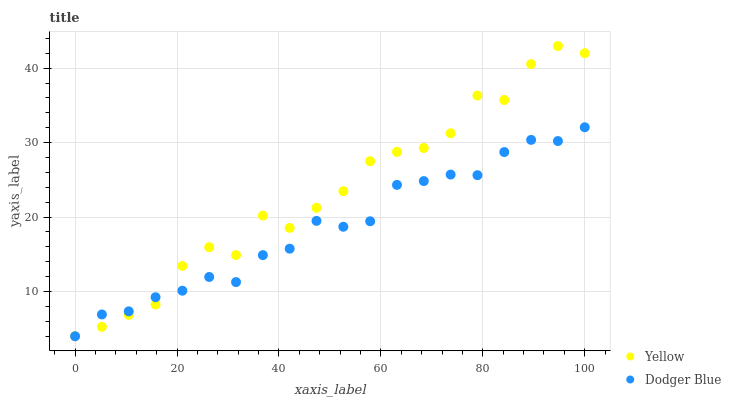Does Dodger Blue have the minimum area under the curve?
Answer yes or no. Yes. Does Yellow have the maximum area under the curve?
Answer yes or no. Yes. Does Yellow have the minimum area under the curve?
Answer yes or no. No. Is Dodger Blue the smoothest?
Answer yes or no. Yes. Is Yellow the roughest?
Answer yes or no. Yes. Is Yellow the smoothest?
Answer yes or no. No. Does Dodger Blue have the lowest value?
Answer yes or no. Yes. Does Yellow have the highest value?
Answer yes or no. Yes. Does Dodger Blue intersect Yellow?
Answer yes or no. Yes. Is Dodger Blue less than Yellow?
Answer yes or no. No. Is Dodger Blue greater than Yellow?
Answer yes or no. No. 